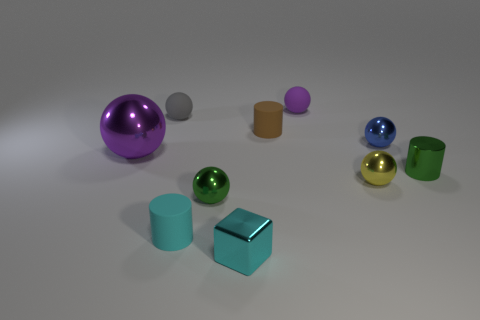Subtract all blue balls. How many balls are left? 5 Subtract all small purple spheres. How many spheres are left? 5 Subtract all gray blocks. Subtract all yellow balls. How many blocks are left? 1 Subtract all balls. How many objects are left? 4 Add 2 big red cylinders. How many big red cylinders exist? 2 Subtract 1 cyan cylinders. How many objects are left? 9 Subtract all tiny green things. Subtract all tiny red things. How many objects are left? 8 Add 6 blue shiny spheres. How many blue shiny spheres are left? 7 